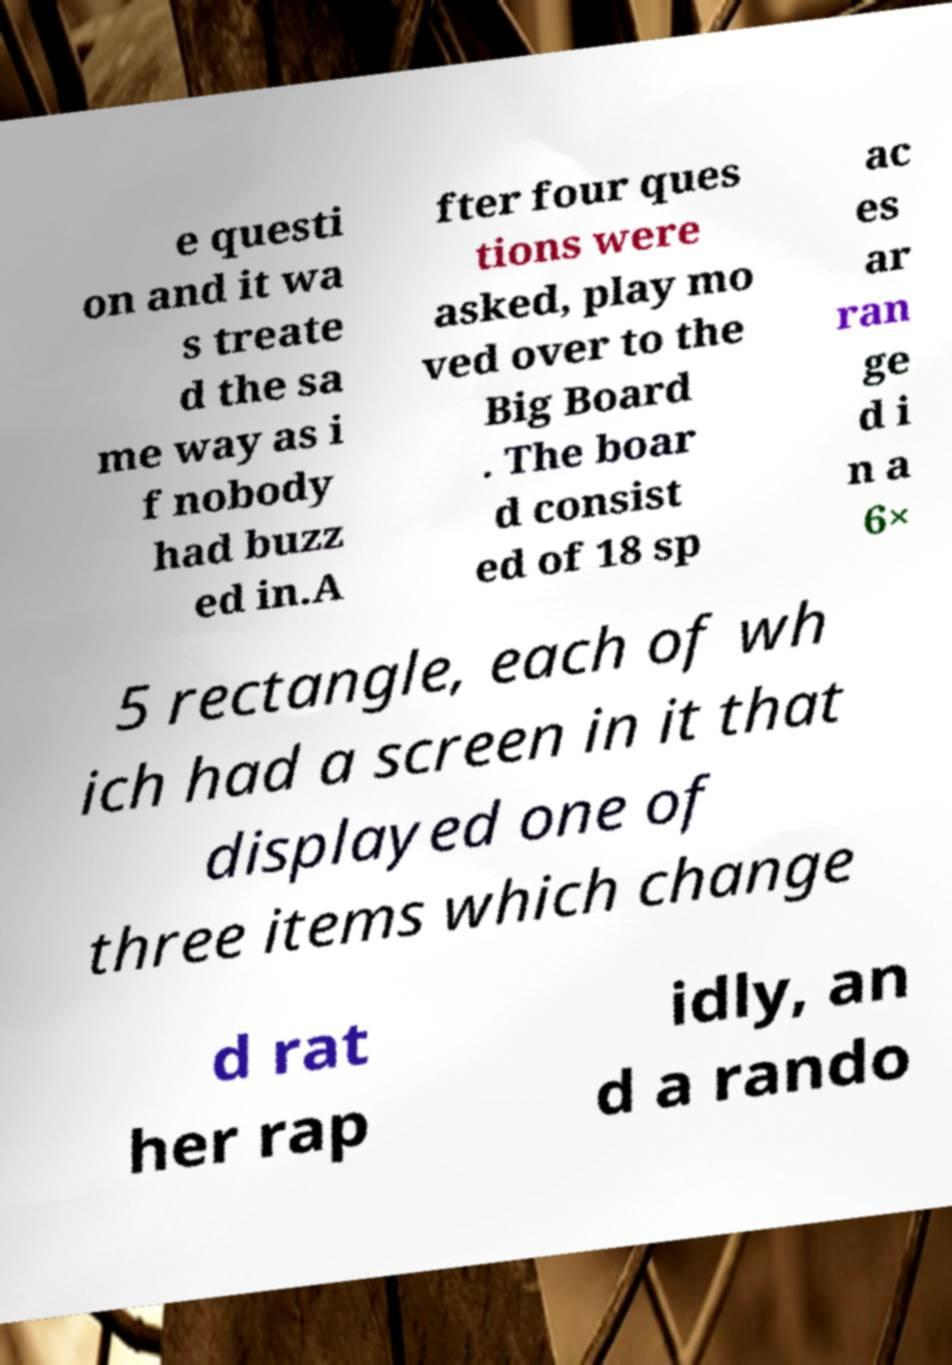What messages or text are displayed in this image? I need them in a readable, typed format. e questi on and it wa s treate d the sa me way as i f nobody had buzz ed in.A fter four ques tions were asked, play mo ved over to the Big Board . The boar d consist ed of 18 sp ac es ar ran ge d i n a 6× 5 rectangle, each of wh ich had a screen in it that displayed one of three items which change d rat her rap idly, an d a rando 